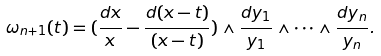Convert formula to latex. <formula><loc_0><loc_0><loc_500><loc_500>\omega _ { n + 1 } ( t ) = ( \frac { d x } { x } - \frac { d ( x - t ) } { ( x - t ) } ) \wedge \frac { d y _ { 1 } } { y _ { 1 } } \wedge \dots \wedge \frac { d y _ { n } } { y _ { n } } .</formula> 